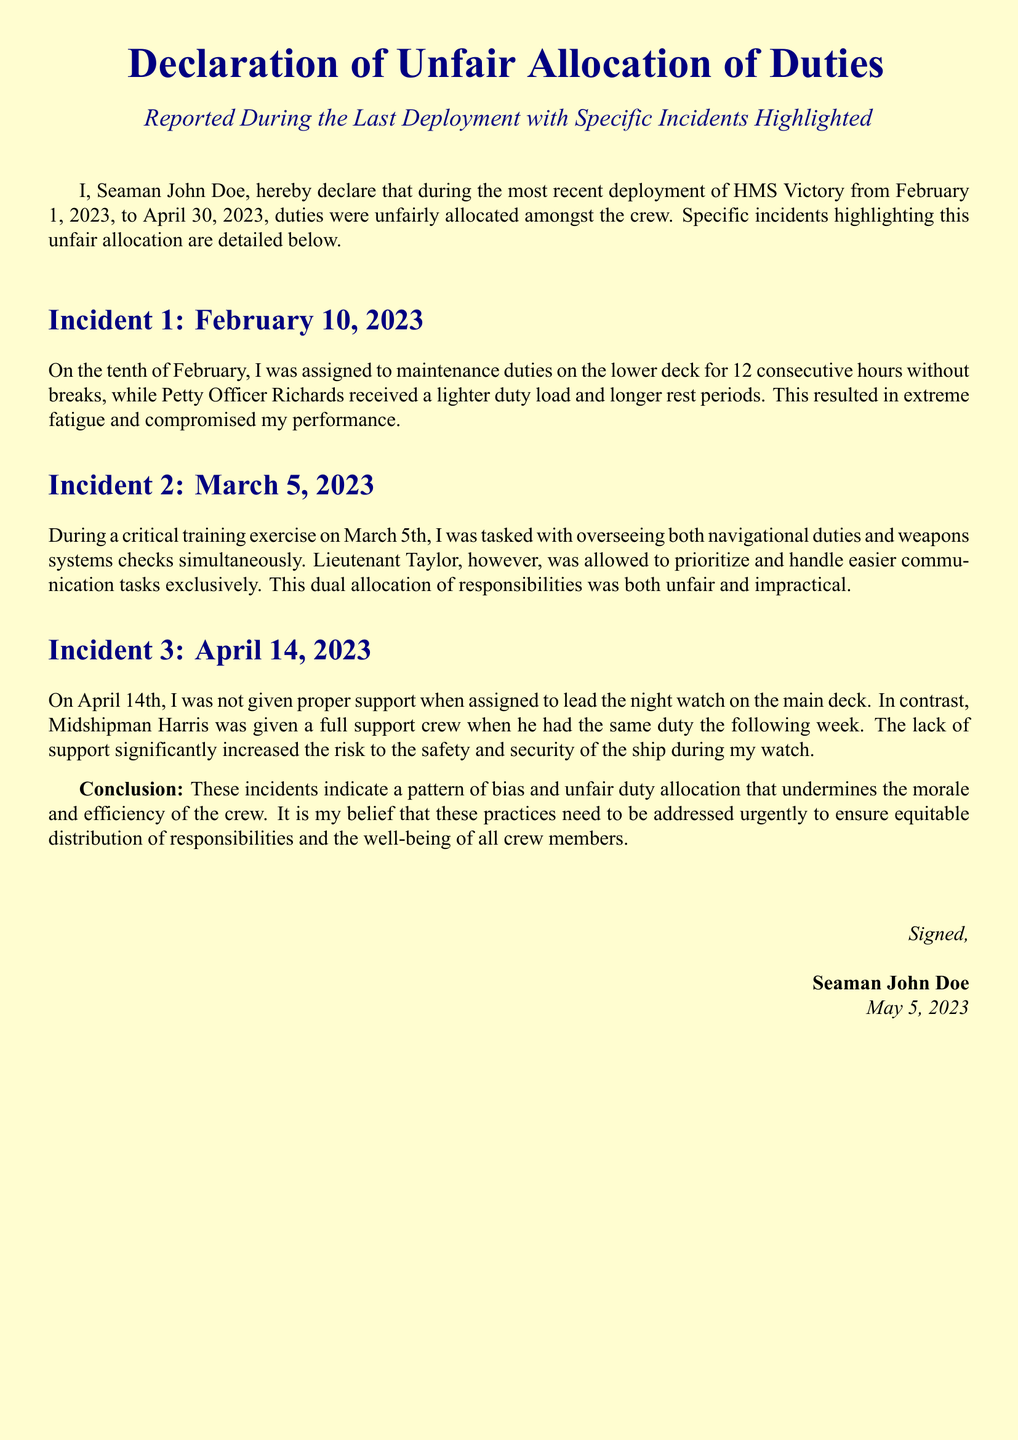What is the declaration about? The declaration addresses unfair allocation of duties reported during the last deployment.
Answer: unfair allocation of duties Who signed the declaration? The declaration was signed by Seaman John Doe.
Answer: Seaman John Doe What date did the most recent deployment start? The deployment started on February 1, 2023.
Answer: February 1, 2023 How long was the maintenance duty assigned to Seaman John Doe on February 10? Seaman John Doe was assigned for 12 consecutive hours without breaks.
Answer: 12 hours Which officer received a lighter duty load on February 10? The officer who received a lighter duty load was Petty Officer Richards.
Answer: Petty Officer Richards On what date did the dual allocation of responsibilities occur? The incident of dual allocation occurred on March 5, 2023.
Answer: March 5, 2023 Who prioritized communication tasks during the exercise on March 5? Lieutenant Taylor prioritized the communication tasks.
Answer: Lieutenant Taylor What was the duty assigned to Seaman John Doe on April 14? Seaman John Doe was assigned to lead the night watch on the main deck.
Answer: lead the night watch What is highlighted as a consequence of the unfair duty allocation? The unfair duty allocation undermines morale and efficiency of the crew.
Answer: morale and efficiency 